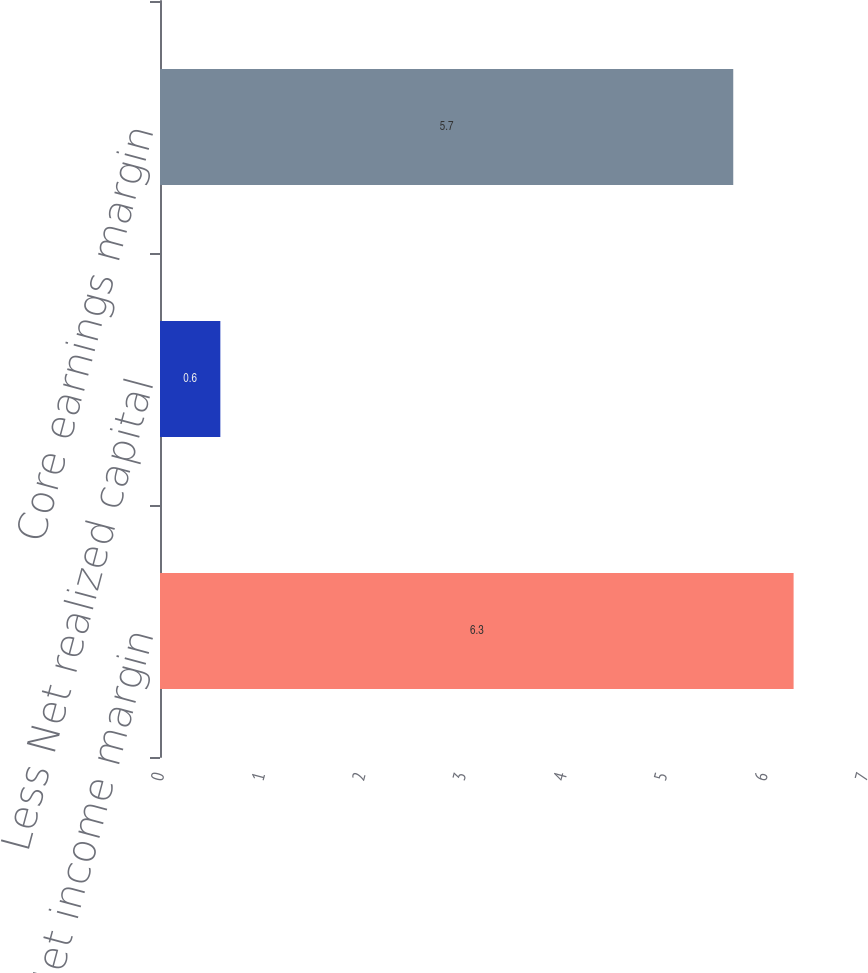Convert chart to OTSL. <chart><loc_0><loc_0><loc_500><loc_500><bar_chart><fcel>Net income margin<fcel>Less Net realized capital<fcel>Core earnings margin<nl><fcel>6.3<fcel>0.6<fcel>5.7<nl></chart> 